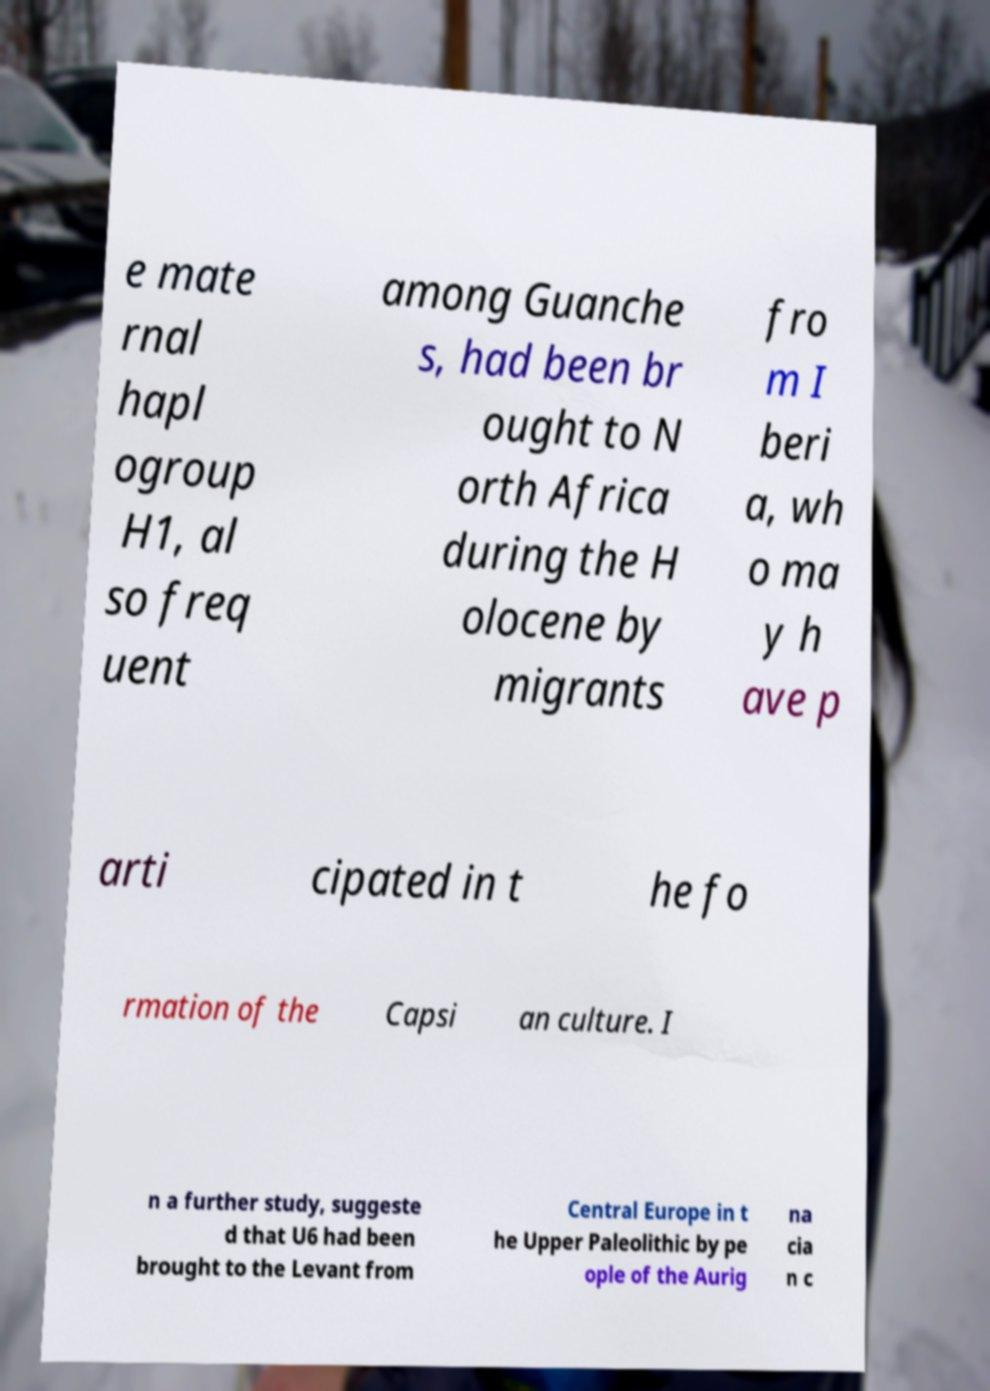Could you extract and type out the text from this image? e mate rnal hapl ogroup H1, al so freq uent among Guanche s, had been br ought to N orth Africa during the H olocene by migrants fro m I beri a, wh o ma y h ave p arti cipated in t he fo rmation of the Capsi an culture. I n a further study, suggeste d that U6 had been brought to the Levant from Central Europe in t he Upper Paleolithic by pe ople of the Aurig na cia n c 